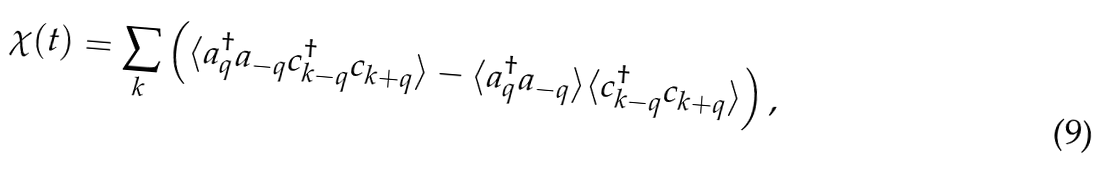Convert formula to latex. <formula><loc_0><loc_0><loc_500><loc_500>\chi ( t ) = \sum _ { k } \left ( \langle a _ { q } ^ { \dagger } a _ { - q } c _ { k - q } ^ { \dagger } c _ { k + q } \rangle - \langle a _ { q } ^ { \dagger } a _ { - q } \rangle \langle c _ { k - q } ^ { \dagger } c _ { k + q } \rangle \right ) ,</formula> 